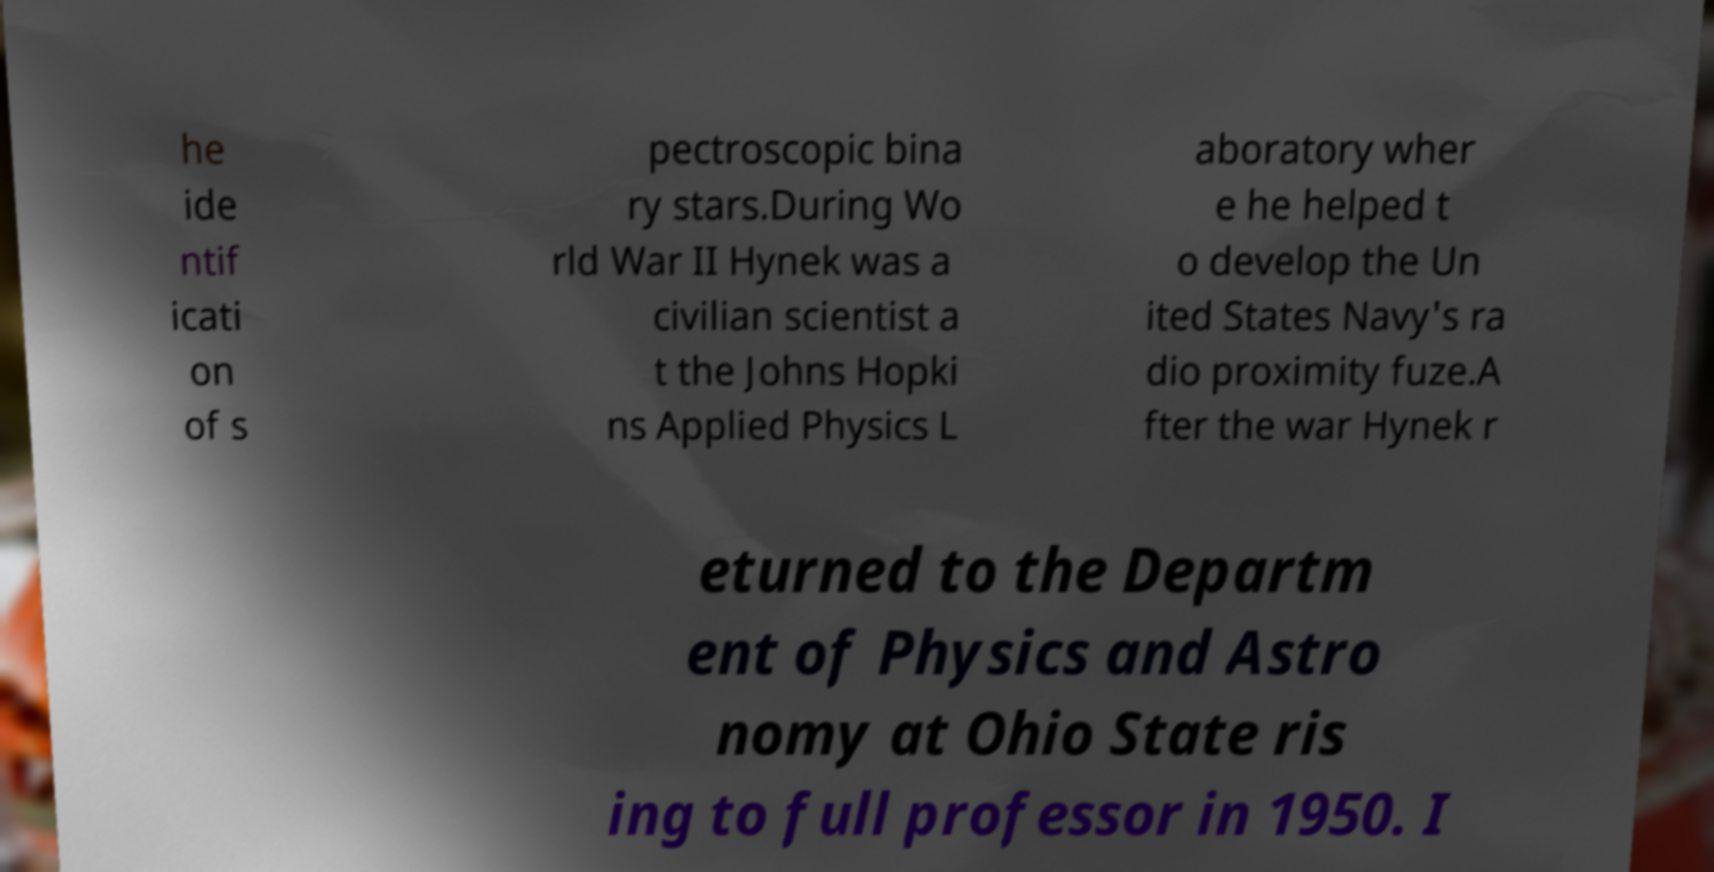I need the written content from this picture converted into text. Can you do that? he ide ntif icati on of s pectroscopic bina ry stars.During Wo rld War II Hynek was a civilian scientist a t the Johns Hopki ns Applied Physics L aboratory wher e he helped t o develop the Un ited States Navy's ra dio proximity fuze.A fter the war Hynek r eturned to the Departm ent of Physics and Astro nomy at Ohio State ris ing to full professor in 1950. I 